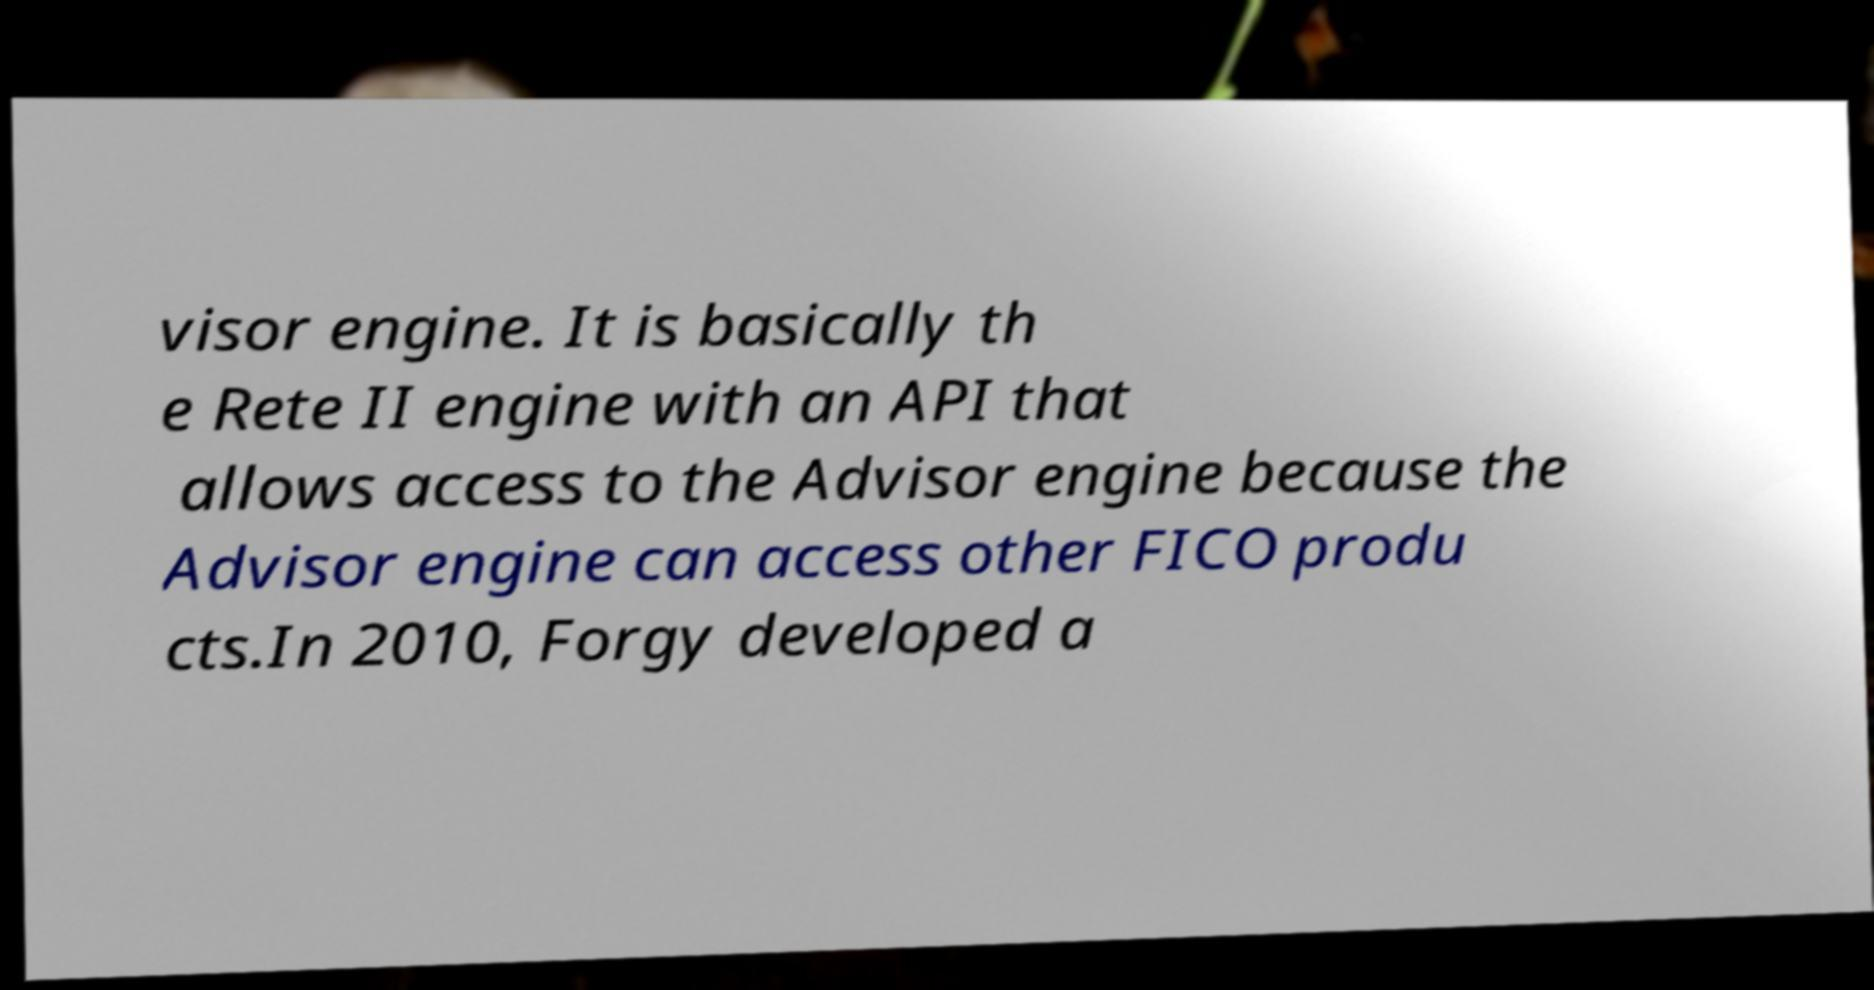Please identify and transcribe the text found in this image. visor engine. It is basically th e Rete II engine with an API that allows access to the Advisor engine because the Advisor engine can access other FICO produ cts.In 2010, Forgy developed a 